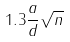<formula> <loc_0><loc_0><loc_500><loc_500>1 . 3 \frac { a } { d } \sqrt { n }</formula> 